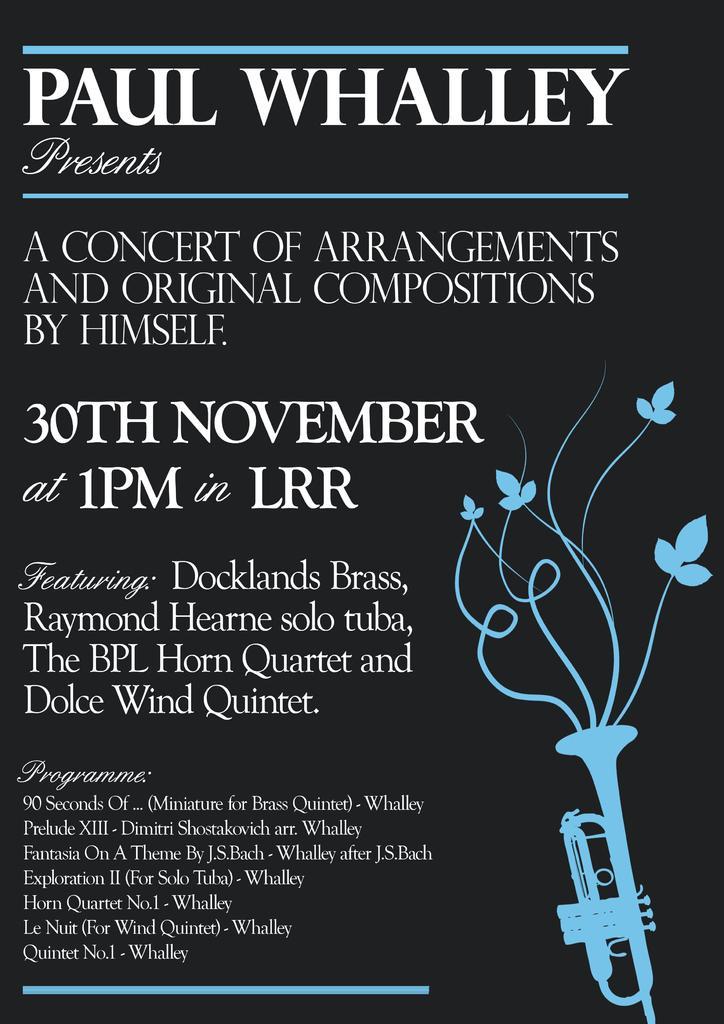Could you give a brief overview of what you see in this image? In this image we can see an invitation of some event which is in black and blue color and there is a trumpet, flowers in it. 